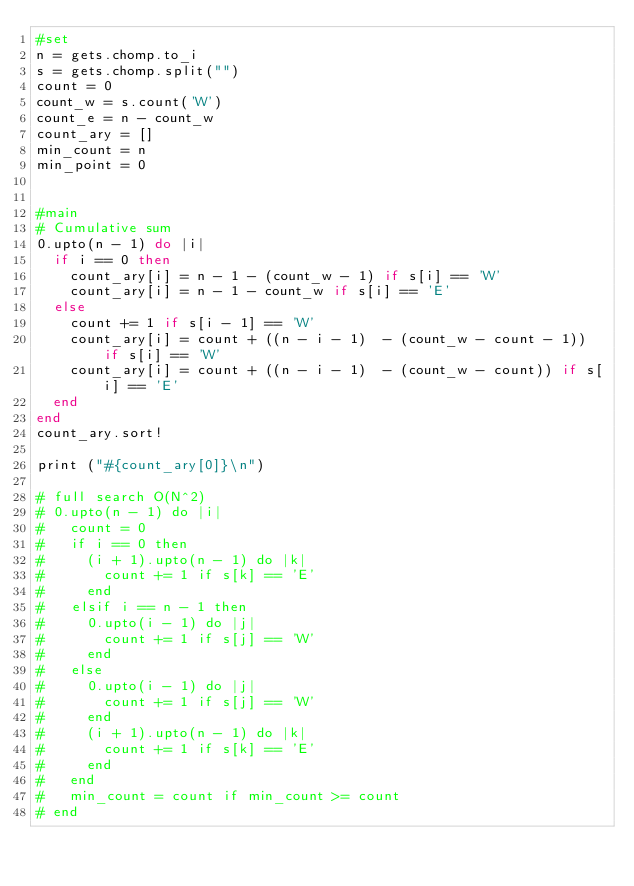<code> <loc_0><loc_0><loc_500><loc_500><_Ruby_>#set
n = gets.chomp.to_i
s = gets.chomp.split("")
count = 0
count_w = s.count('W')
count_e = n - count_w
count_ary = []
min_count = n
min_point = 0


#main
# Cumulative sum
0.upto(n - 1) do |i|
  if i == 0 then
    count_ary[i] = n - 1 - (count_w - 1) if s[i] == 'W'
    count_ary[i] = n - 1 - count_w if s[i] == 'E'
  else
    count += 1 if s[i - 1] == 'W'
    count_ary[i] = count + ((n - i - 1)  - (count_w - count - 1)) if s[i] == 'W'
    count_ary[i] = count + ((n - i - 1)  - (count_w - count)) if s[i] == 'E'
  end
end
count_ary.sort!

print ("#{count_ary[0]}\n")

# full search O(N^2)
# 0.upto(n - 1) do |i|
#   count = 0
#   if i == 0 then
#     (i + 1).upto(n - 1) do |k|
#       count += 1 if s[k] == 'E'
#     end
#   elsif i == n - 1 then
#     0.upto(i - 1) do |j|
#       count += 1 if s[j] == 'W'
#     end
#   else
#     0.upto(i - 1) do |j|
#       count += 1 if s[j] == 'W'
#     end
#     (i + 1).upto(n - 1) do |k|
#       count += 1 if s[k] == 'E'
#     end
#   end
#   min_count = count if min_count >= count
# end

</code> 